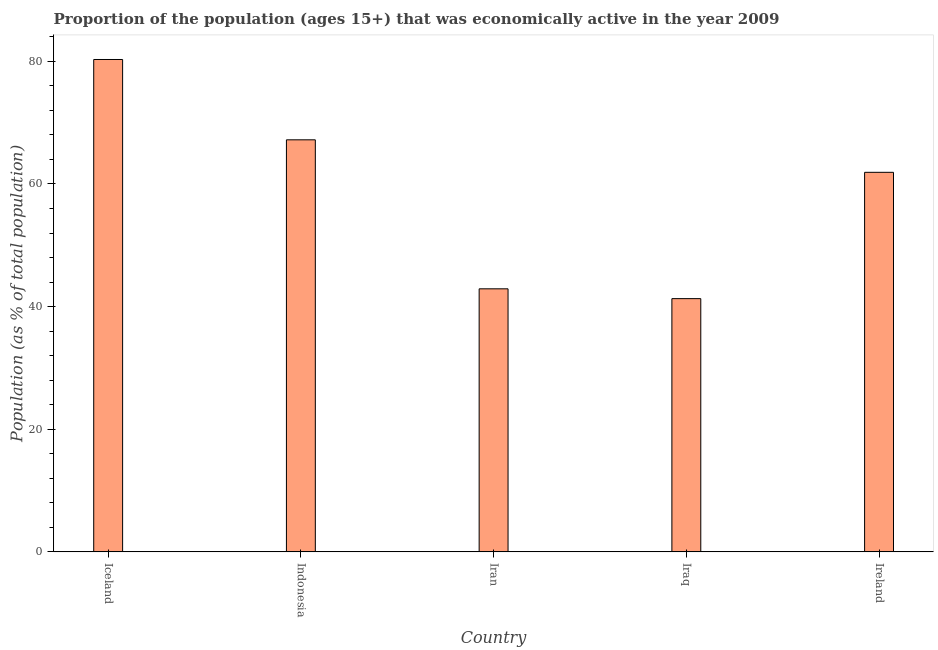Does the graph contain any zero values?
Your response must be concise. No. What is the title of the graph?
Provide a short and direct response. Proportion of the population (ages 15+) that was economically active in the year 2009. What is the label or title of the Y-axis?
Provide a succinct answer. Population (as % of total population). What is the percentage of economically active population in Iraq?
Keep it short and to the point. 41.3. Across all countries, what is the maximum percentage of economically active population?
Your response must be concise. 80.3. Across all countries, what is the minimum percentage of economically active population?
Ensure brevity in your answer.  41.3. In which country was the percentage of economically active population minimum?
Your answer should be very brief. Iraq. What is the sum of the percentage of economically active population?
Your answer should be compact. 293.6. What is the difference between the percentage of economically active population in Iran and Iraq?
Make the answer very short. 1.6. What is the average percentage of economically active population per country?
Offer a very short reply. 58.72. What is the median percentage of economically active population?
Provide a short and direct response. 61.9. In how many countries, is the percentage of economically active population greater than 56 %?
Offer a terse response. 3. What is the ratio of the percentage of economically active population in Iraq to that in Ireland?
Provide a succinct answer. 0.67. Is the percentage of economically active population in Iran less than that in Iraq?
Ensure brevity in your answer.  No. Is the sum of the percentage of economically active population in Iran and Iraq greater than the maximum percentage of economically active population across all countries?
Make the answer very short. Yes. What is the difference between the highest and the lowest percentage of economically active population?
Ensure brevity in your answer.  39. In how many countries, is the percentage of economically active population greater than the average percentage of economically active population taken over all countries?
Offer a terse response. 3. How many countries are there in the graph?
Your response must be concise. 5. What is the Population (as % of total population) in Iceland?
Make the answer very short. 80.3. What is the Population (as % of total population) of Indonesia?
Offer a very short reply. 67.2. What is the Population (as % of total population) in Iran?
Keep it short and to the point. 42.9. What is the Population (as % of total population) of Iraq?
Offer a terse response. 41.3. What is the Population (as % of total population) in Ireland?
Keep it short and to the point. 61.9. What is the difference between the Population (as % of total population) in Iceland and Indonesia?
Provide a succinct answer. 13.1. What is the difference between the Population (as % of total population) in Iceland and Iran?
Give a very brief answer. 37.4. What is the difference between the Population (as % of total population) in Iceland and Ireland?
Keep it short and to the point. 18.4. What is the difference between the Population (as % of total population) in Indonesia and Iran?
Make the answer very short. 24.3. What is the difference between the Population (as % of total population) in Indonesia and Iraq?
Offer a terse response. 25.9. What is the difference between the Population (as % of total population) in Indonesia and Ireland?
Provide a short and direct response. 5.3. What is the difference between the Population (as % of total population) in Iraq and Ireland?
Provide a short and direct response. -20.6. What is the ratio of the Population (as % of total population) in Iceland to that in Indonesia?
Provide a succinct answer. 1.2. What is the ratio of the Population (as % of total population) in Iceland to that in Iran?
Give a very brief answer. 1.87. What is the ratio of the Population (as % of total population) in Iceland to that in Iraq?
Your response must be concise. 1.94. What is the ratio of the Population (as % of total population) in Iceland to that in Ireland?
Your answer should be compact. 1.3. What is the ratio of the Population (as % of total population) in Indonesia to that in Iran?
Your response must be concise. 1.57. What is the ratio of the Population (as % of total population) in Indonesia to that in Iraq?
Your response must be concise. 1.63. What is the ratio of the Population (as % of total population) in Indonesia to that in Ireland?
Ensure brevity in your answer.  1.09. What is the ratio of the Population (as % of total population) in Iran to that in Iraq?
Provide a succinct answer. 1.04. What is the ratio of the Population (as % of total population) in Iran to that in Ireland?
Make the answer very short. 0.69. What is the ratio of the Population (as % of total population) in Iraq to that in Ireland?
Your response must be concise. 0.67. 